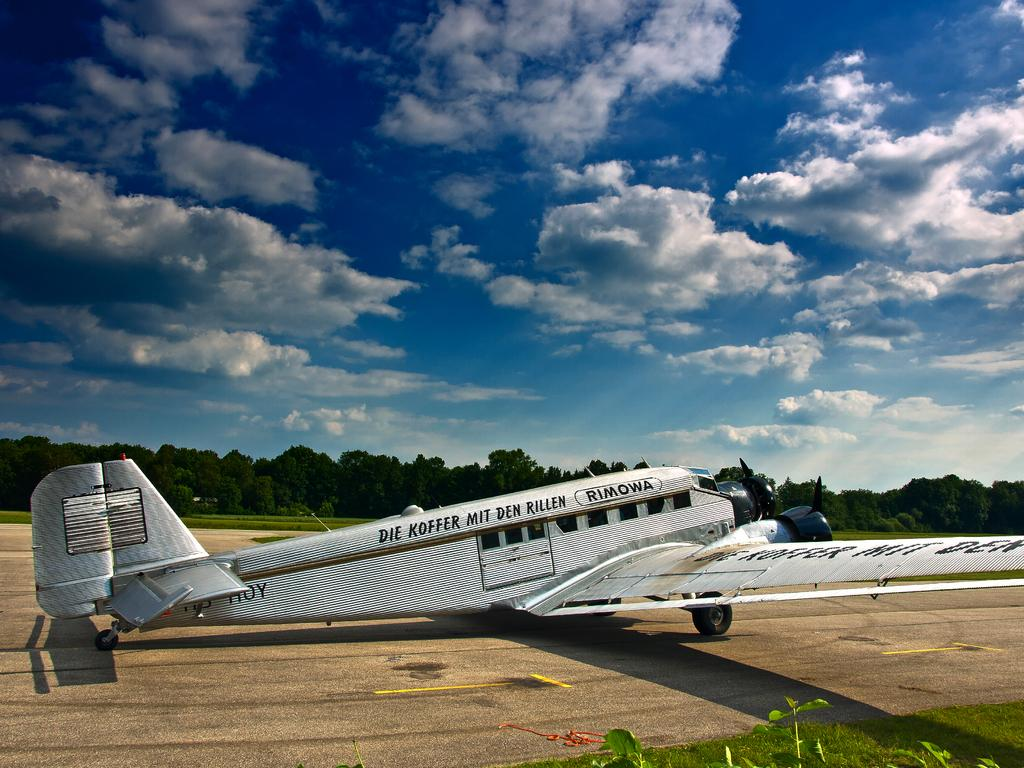<image>
Share a concise interpretation of the image provided. The vintage Rimowa plane is parked on the runway. 